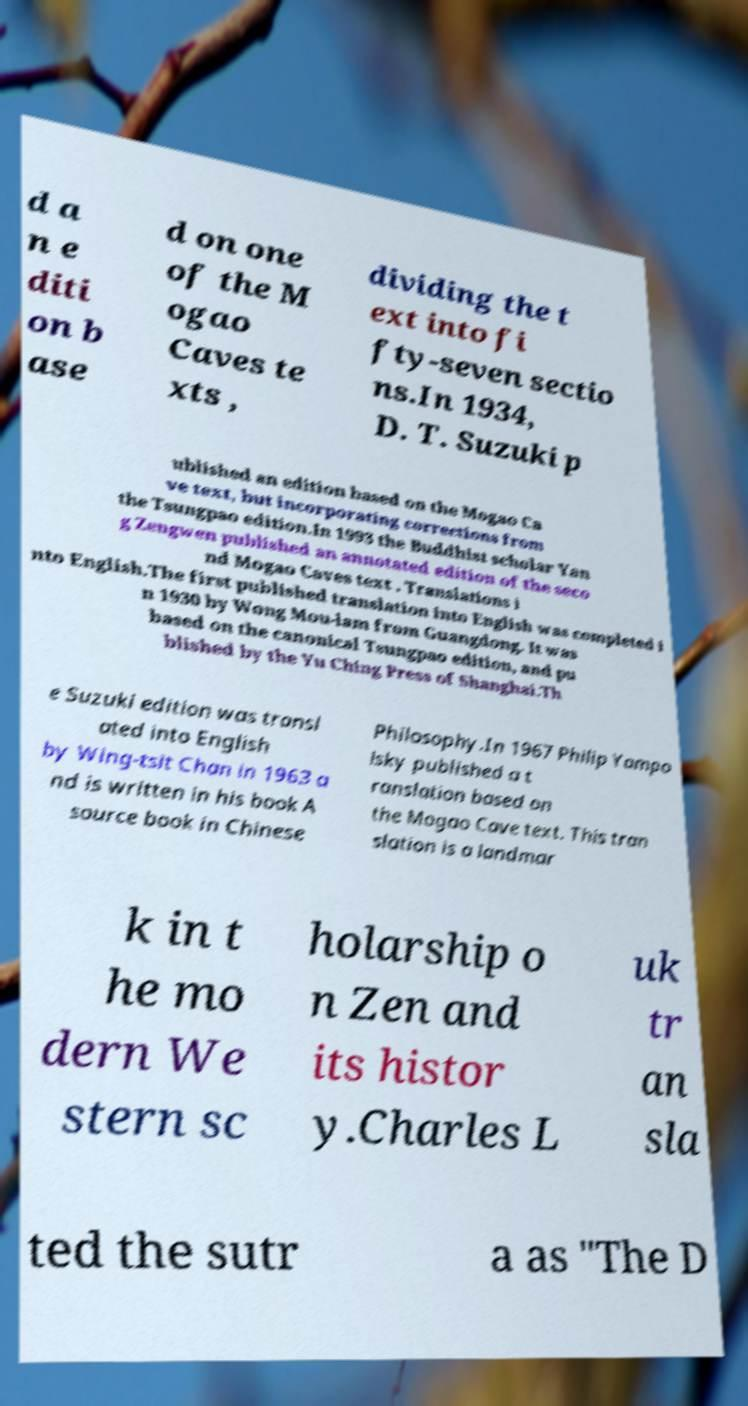I need the written content from this picture converted into text. Can you do that? d a n e diti on b ase d on one of the M ogao Caves te xts , dividing the t ext into fi fty-seven sectio ns.In 1934, D. T. Suzuki p ublished an edition based on the Mogao Ca ve text, but incorporating corrections from the Tsungpao edition.In 1993 the Buddhist scholar Yan g Zengwen published an annotated edition of the seco nd Mogao Caves text . Translations i nto English.The first published translation into English was completed i n 1930 by Wong Mou-lam from Guangdong. It was based on the canonical Tsungpao edition, and pu blished by the Yu Ching Press of Shanghai.Th e Suzuki edition was transl ated into English by Wing-tsit Chan in 1963 a nd is written in his book A source book in Chinese Philosophy.In 1967 Philip Yampo lsky published a t ranslation based on the Mogao Cave text. This tran slation is a landmar k in t he mo dern We stern sc holarship o n Zen and its histor y.Charles L uk tr an sla ted the sutr a as "The D 